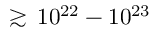Convert formula to latex. <formula><loc_0><loc_0><loc_500><loc_500>\gtrsim \, 1 0 ^ { 2 2 } - 1 0 ^ { 2 3 }</formula> 